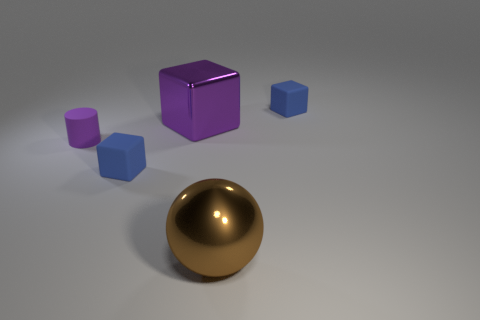Subtract all blue matte blocks. How many blocks are left? 1 Add 2 big green balls. How many objects exist? 7 Subtract all purple blocks. How many blocks are left? 2 Subtract all blocks. How many objects are left? 2 Subtract 3 cubes. How many cubes are left? 0 Subtract all red spheres. How many blue cubes are left? 2 Subtract all tiny green shiny things. Subtract all brown shiny objects. How many objects are left? 4 Add 2 big shiny cubes. How many big shiny cubes are left? 3 Add 2 purple blocks. How many purple blocks exist? 3 Subtract 0 yellow spheres. How many objects are left? 5 